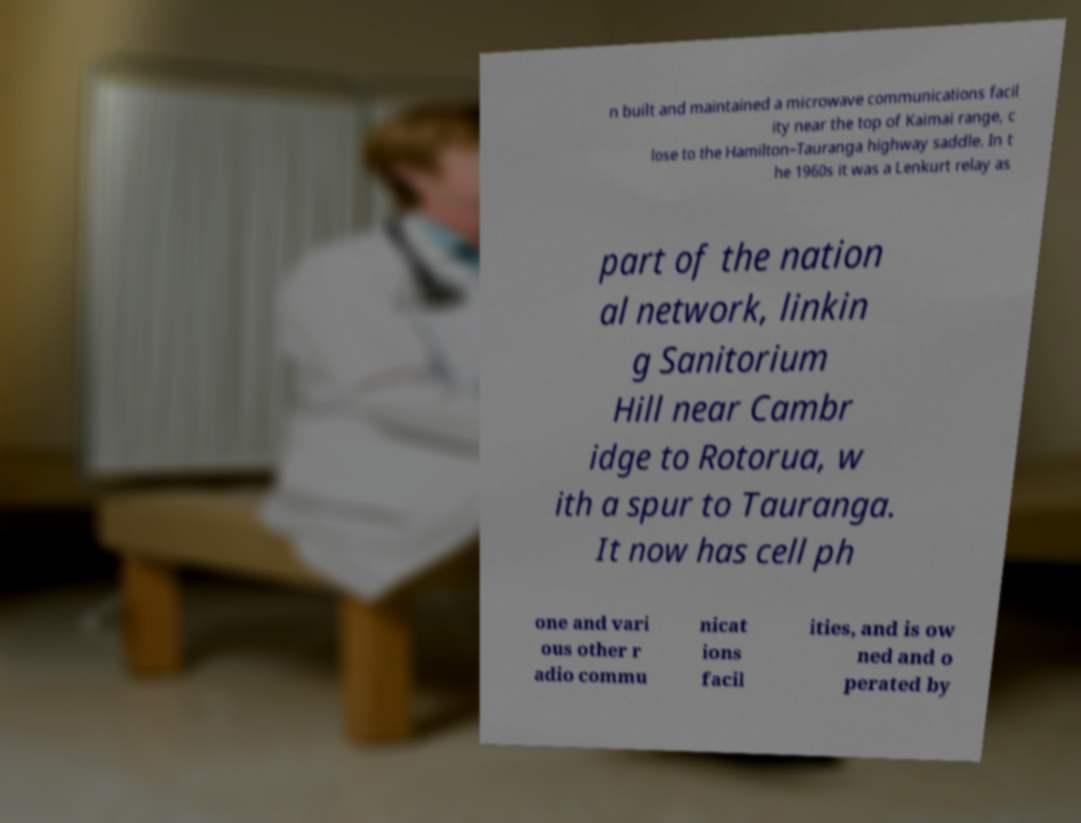Can you read and provide the text displayed in the image?This photo seems to have some interesting text. Can you extract and type it out for me? n built and maintained a microwave communications facil ity near the top of Kaimai range, c lose to the Hamilton–Tauranga highway saddle. In t he 1960s it was a Lenkurt relay as part of the nation al network, linkin g Sanitorium Hill near Cambr idge to Rotorua, w ith a spur to Tauranga. It now has cell ph one and vari ous other r adio commu nicat ions facil ities, and is ow ned and o perated by 